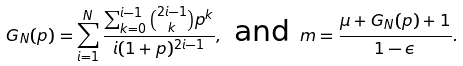<formula> <loc_0><loc_0><loc_500><loc_500>G _ { N } ( p ) = \sum _ { i = 1 } ^ { N } \frac { \sum _ { k = 0 } ^ { i - 1 } \binom { 2 i - 1 } { k } p ^ { k } } { i ( 1 + p ) ^ { 2 i - 1 } } , \text {   and } m = \frac { \mu + G _ { N } ( p ) + 1 } { 1 - \epsilon } .</formula> 